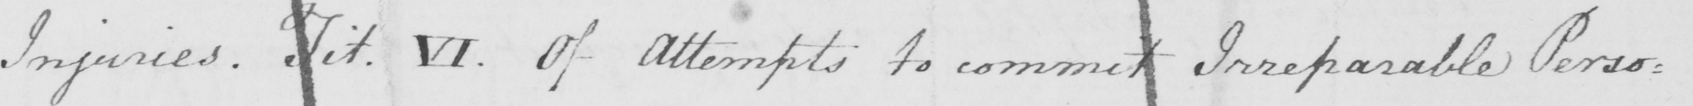What does this handwritten line say? Injuries .  Tit . VI . Of attempts to commit Irreparable Perso= 